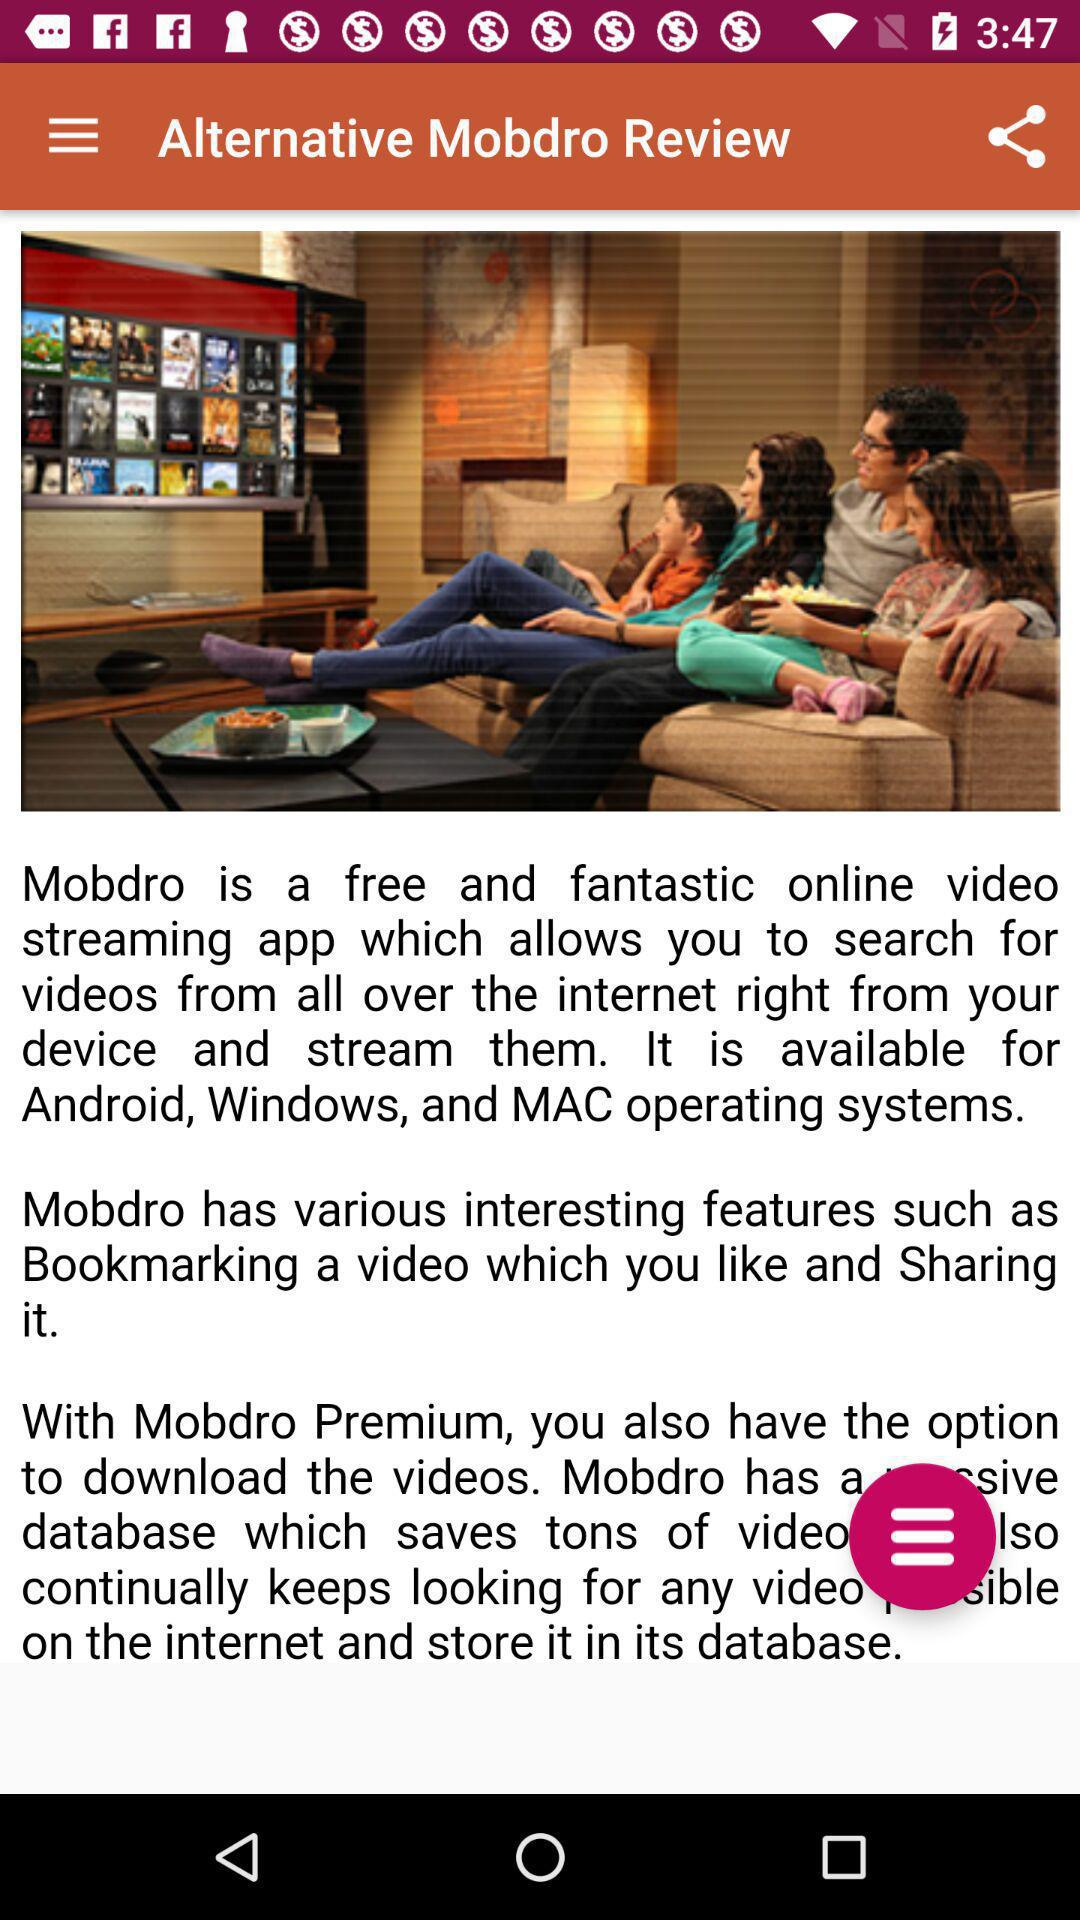For which operating system is the "Mobdro" app available? The "Mobdro" app is available for Android, Windows and MAC operating systems. 